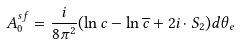<formula> <loc_0><loc_0><loc_500><loc_500>A _ { 0 } ^ { s f } = \frac { i } { 8 \pi ^ { 2 } } ( \ln c - \ln \overline { c } + 2 i \cdot S _ { 2 } ) d \theta _ { e }</formula> 